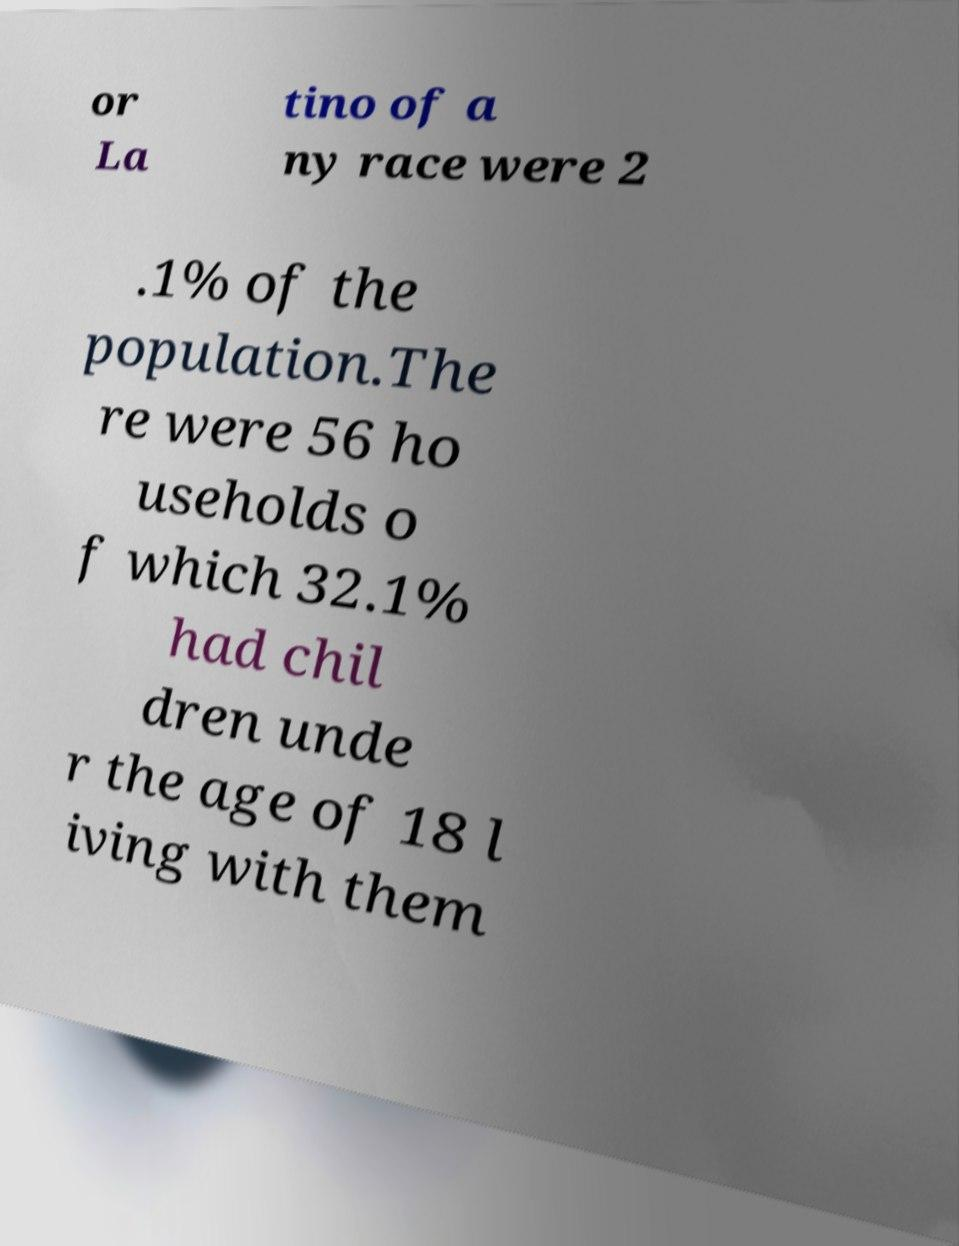For documentation purposes, I need the text within this image transcribed. Could you provide that? or La tino of a ny race were 2 .1% of the population.The re were 56 ho useholds o f which 32.1% had chil dren unde r the age of 18 l iving with them 